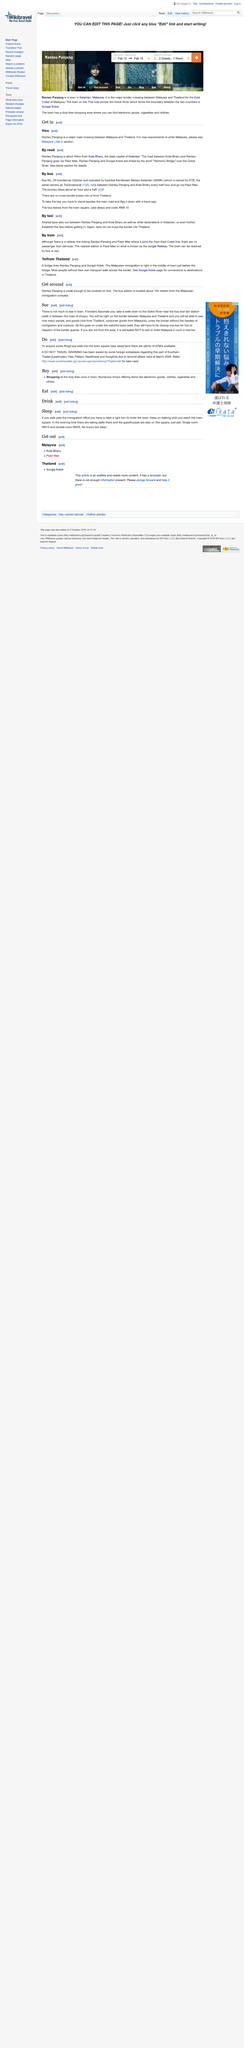Specify some key components in this picture. The Cityliner bus service runs between Rantau Panjang and Kota Bharu, with bus No. 29 operating every half hour, providing a direct connection between the two destinations. Pantau Panjang is approximately 45 kilometers away from Kota Bharu. The bus journey between Rantau Panjang and Kota Bharu takes approximately an hour and a half. 